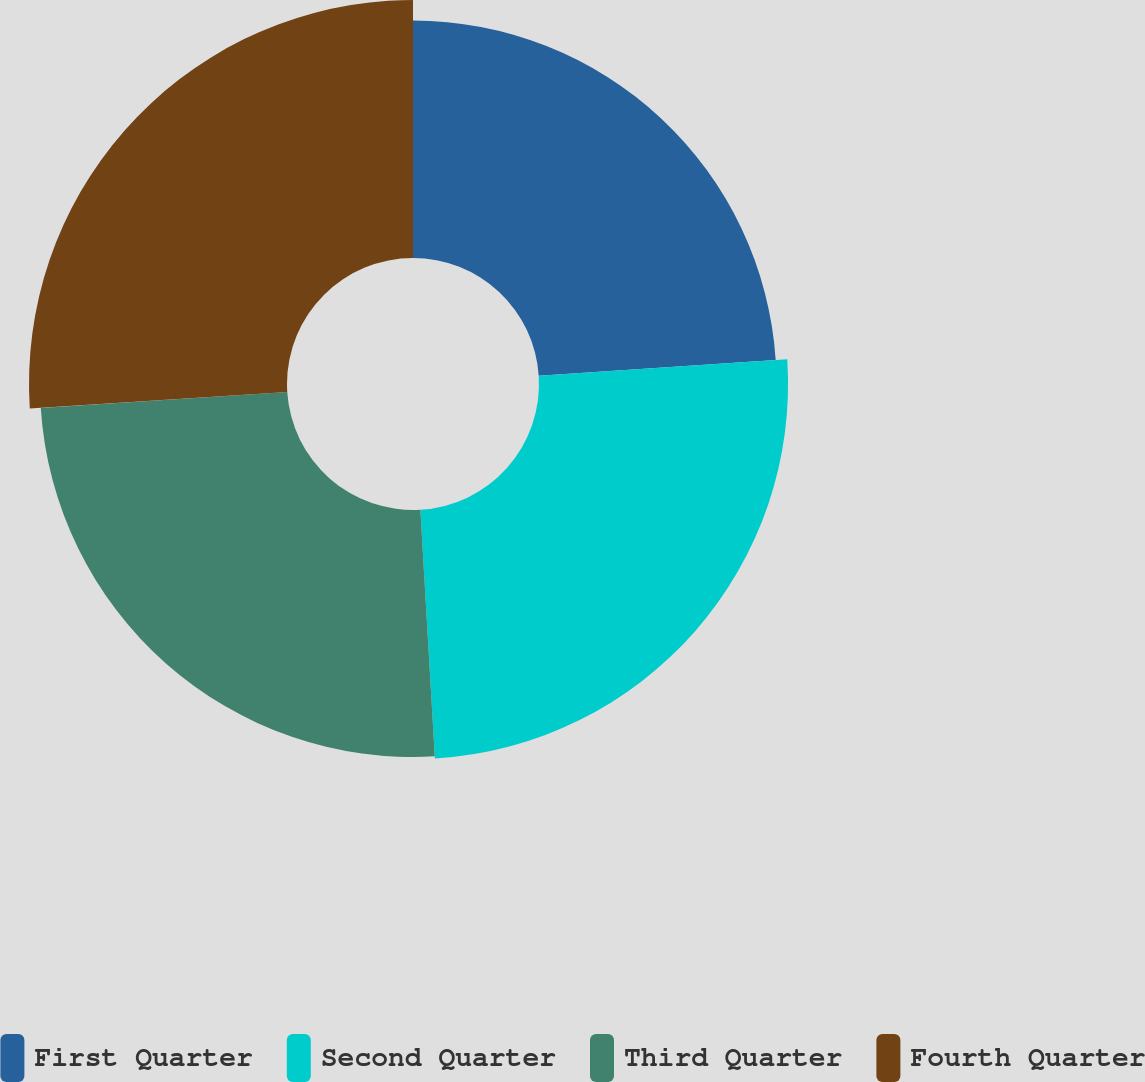<chart> <loc_0><loc_0><loc_500><loc_500><pie_chart><fcel>First Quarter<fcel>Second Quarter<fcel>Third Quarter<fcel>Fourth Quarter<nl><fcel>23.95%<fcel>25.12%<fcel>24.91%<fcel>26.02%<nl></chart> 